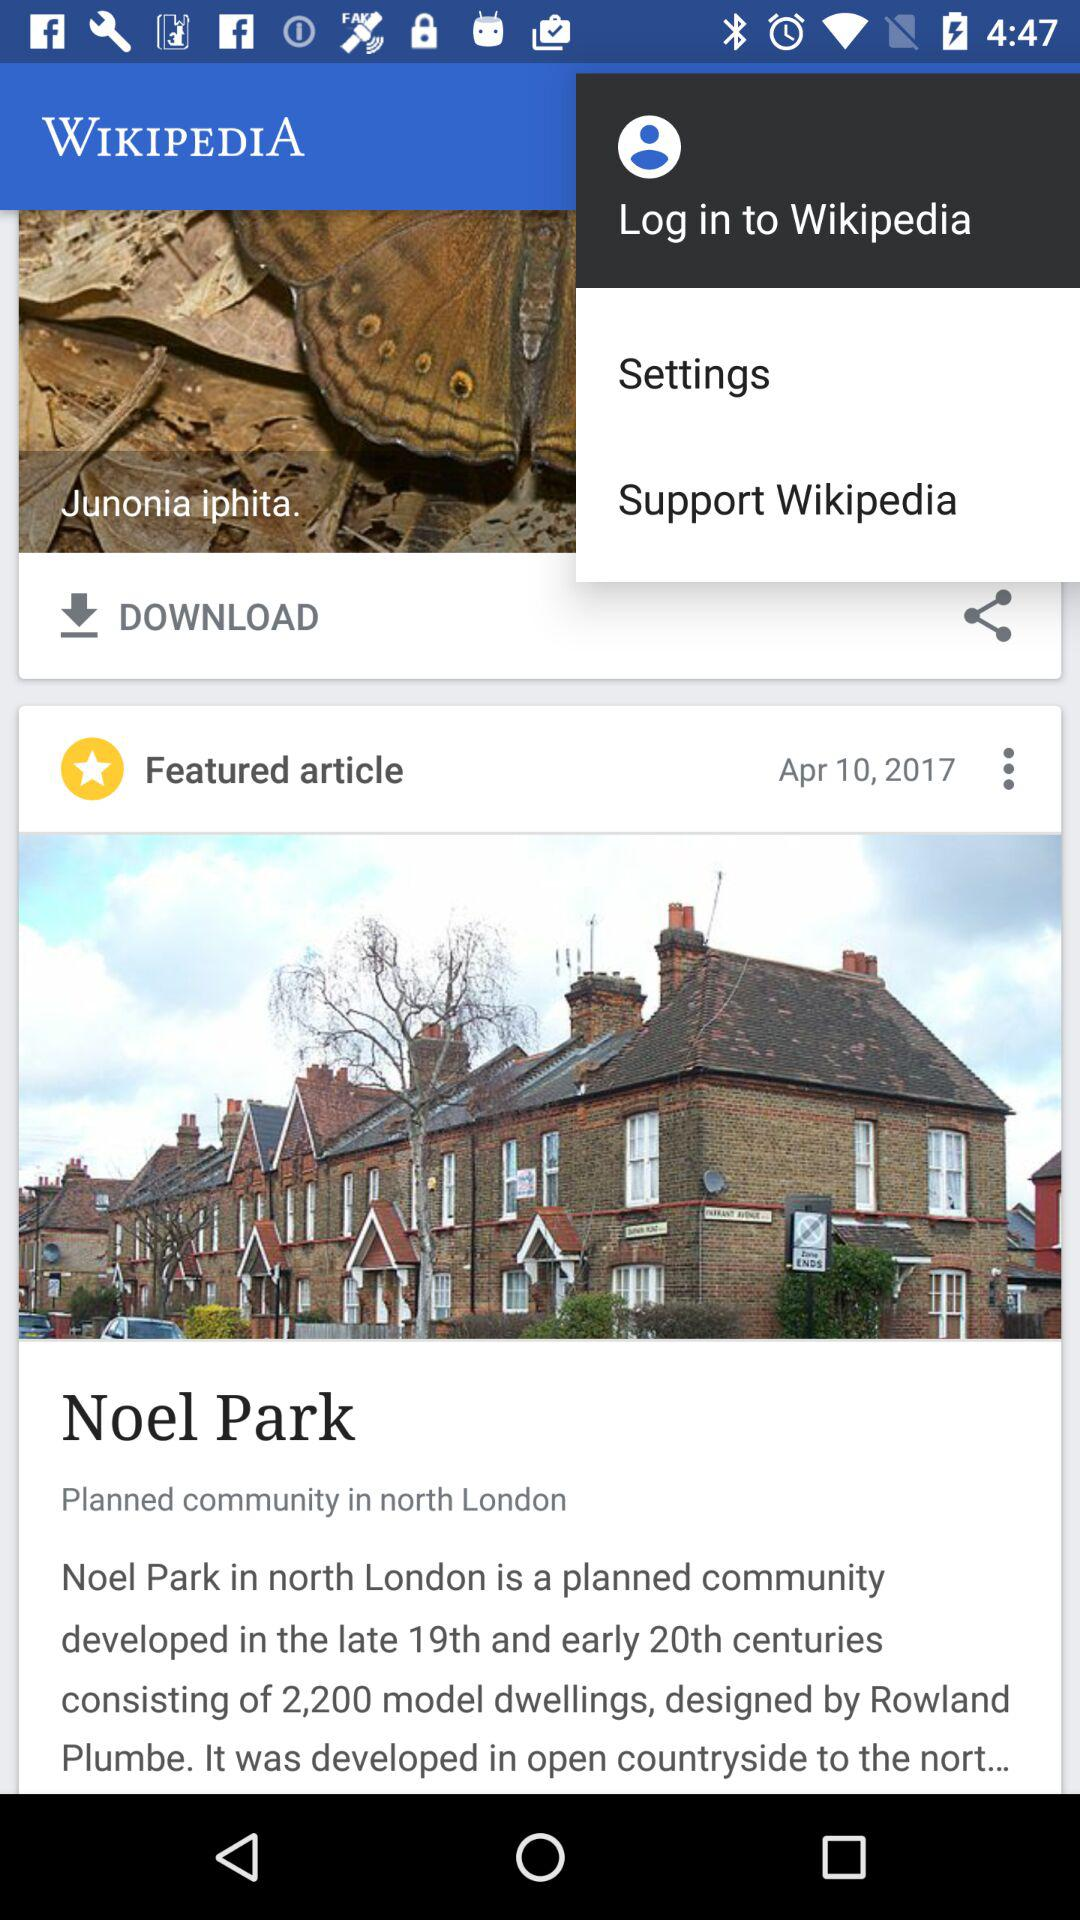What is the article about? The article is about Noel Park. 